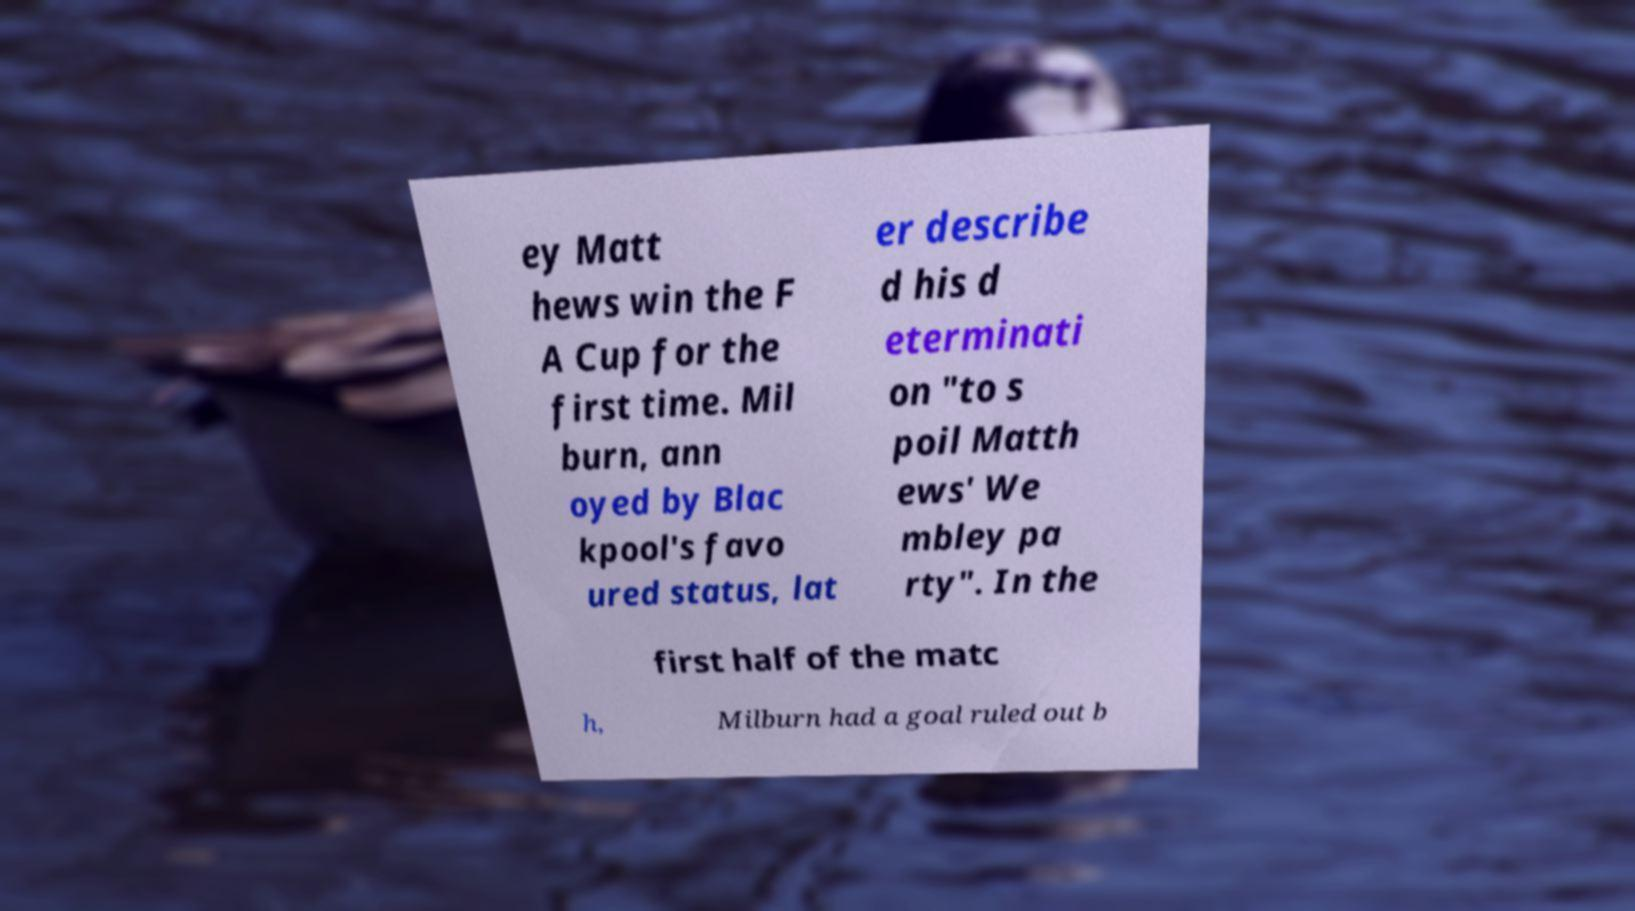Please read and relay the text visible in this image. What does it say? ey Matt hews win the F A Cup for the first time. Mil burn, ann oyed by Blac kpool's favo ured status, lat er describe d his d eterminati on "to s poil Matth ews' We mbley pa rty". In the first half of the matc h, Milburn had a goal ruled out b 